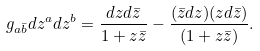<formula> <loc_0><loc_0><loc_500><loc_500>g _ { a \bar { b } } d z ^ { a } d z ^ { b } = \frac { d z d { \bar { z } } } { 1 + z \bar { z } } - \frac { ( { \bar { z } } d z ) ( z d { \bar { z } } ) } { ( 1 + z \bar { z } ) } .</formula> 